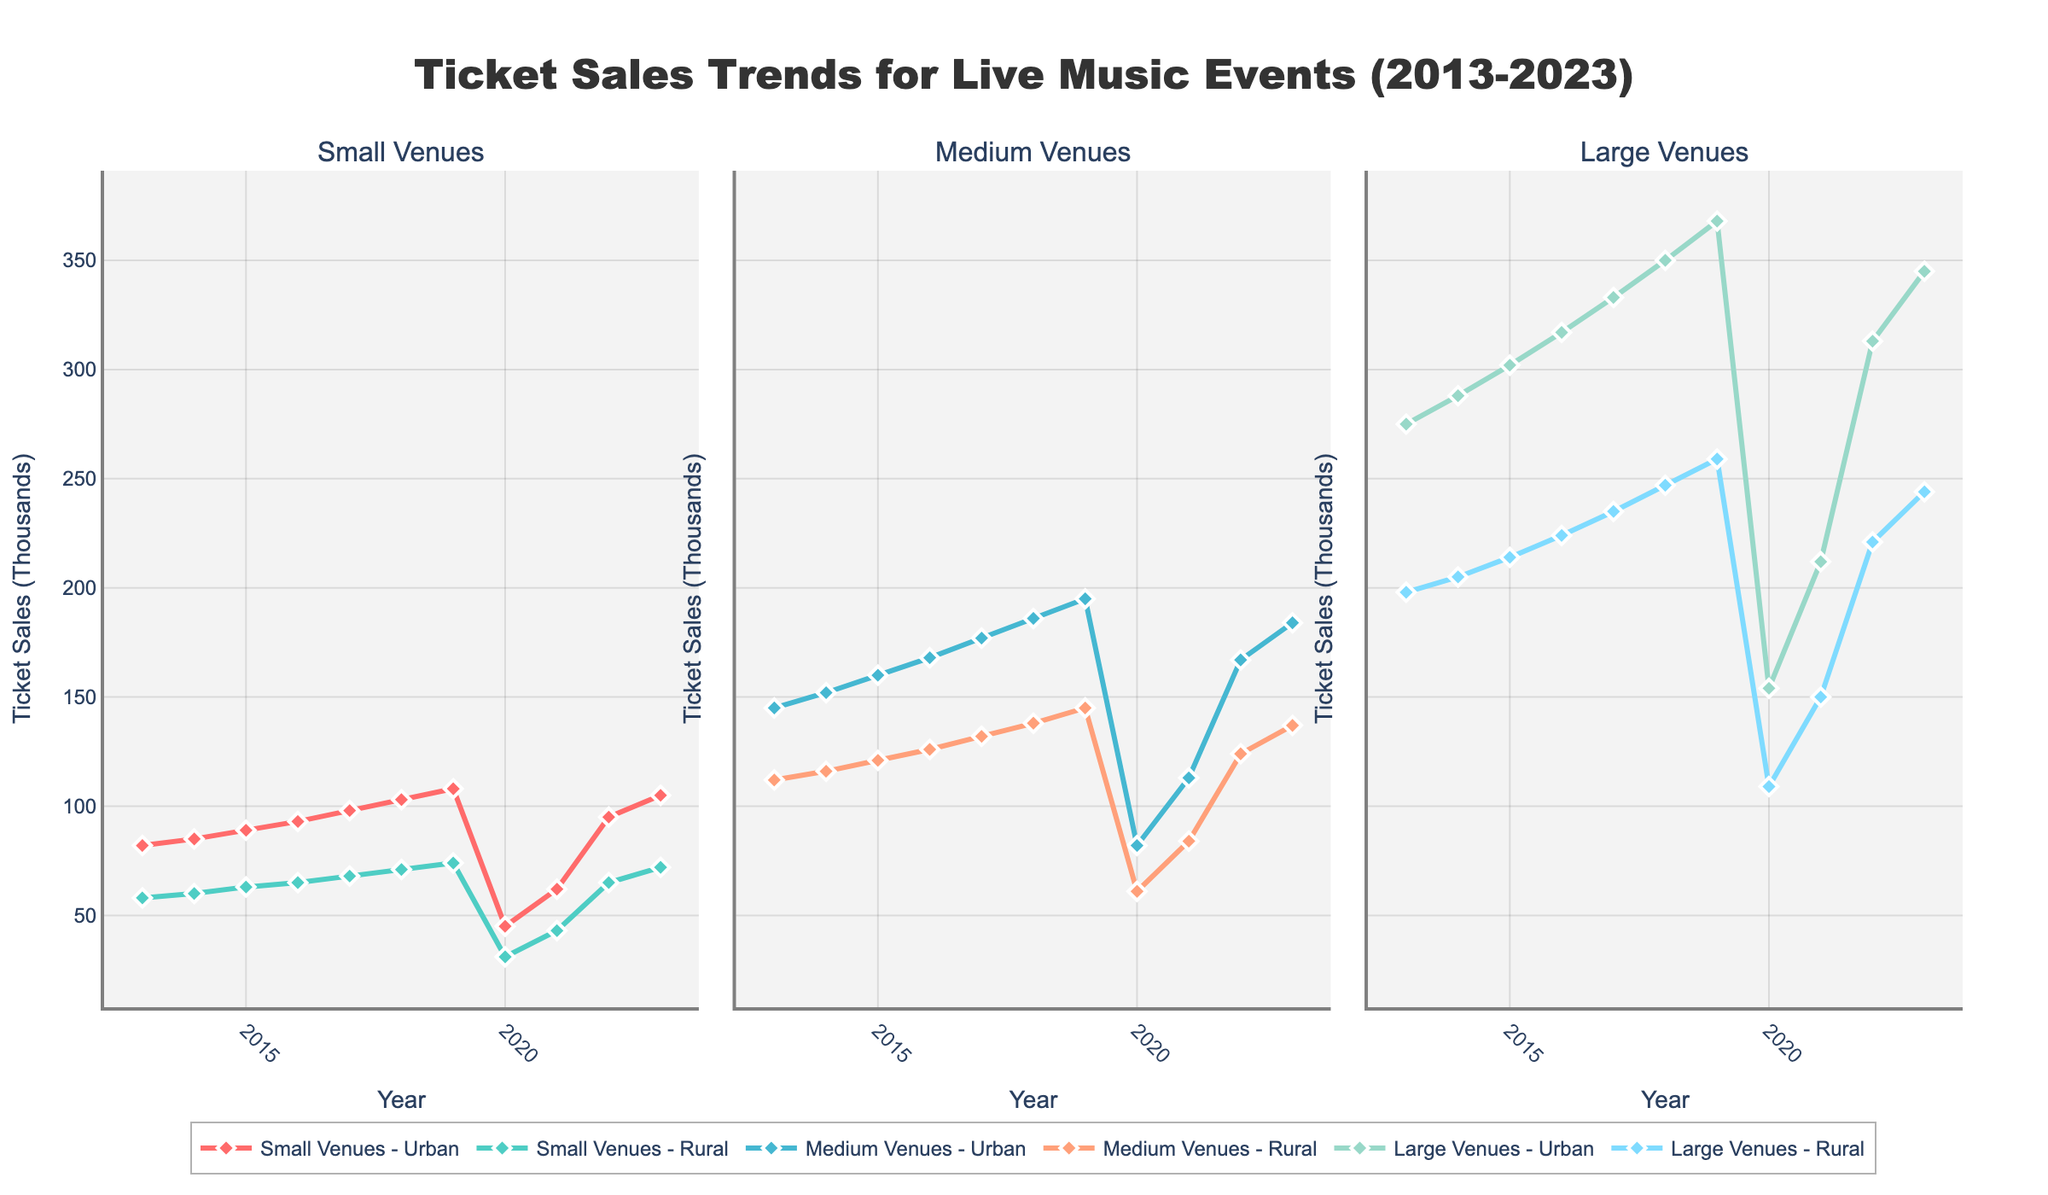How did ticket sales for large venues in urban locations change from 2013 to 2023? Ticket sales for large venues in urban locations increased from 275,000 in 2013 to 345,000 in 2023, which indicates a positive trend. To answer, we locate the 2013 and 2023 data points for large venues in urban locations and observe the rise in values.
Answer: Increased from 275,000 to 345,000 Which venue type and location experienced the greatest decrease in ticket sales in 2020 compared to 2019? The greatest decrease is observed by comparing 2019 and 2020 ticket sales across all venue types and locations. For large venues in urban locations, sales fell from 368,000 in 2019 to 154,000 in 2020. This large drop highlights the significant impact.
Answer: Large Venues Urban By how much did ticket sales for medium venues in rural areas recover from 2020 to 2023? Ticket sales for medium venues in rural areas rose from 61,000 in 2020 to 137,000 in 2023. First, subtract the 2020 value from the 2023 value (137 - 61), resulting in a recovery of 76,000.
Answer: 76,000 Compare the ticket sales trends for small venues in urban and rural locations over the last decade. Analyze both trend lines: small urban venues increased steadily until 2019, dropped in 2020, and then recovered, surpassing their previous peak by 2023. Small rural venues show a similar pattern but with lower values throughout.
Answer: Similar pattern with lower values in rural What's the average annual ticket sales for large venues in rural areas from 2013 to 2023? The average annual ticket sales are calculated by summing the values from 2013 to 2023 and dividing by the count of years. (198 + 205 + 214 + 224 + 235 + 247 + 259 + 109 + 150 + 221 + 244) / 11.
Answer: 212,273 In which year did small venues in urban locations first exceed 100,000 ticket sales? Observe the trend line for small urban venues and identify the first year the value crosses 100,000. In 2018, ticket sales reached 103,000 for small urban venues.
Answer: 2018 How do the trends in large venues compare between urban and rural areas after the 2020 decline? After 2020, ticket sales for both urban and rural large venues recover, but urban areas experience a sharper increase (reaching 345,000), while rural areas grow at a slower pace (up to 244,000).
Answer: Urban areas had a sharper recovery What's the sum of ticket sales for small venues in rural locations from 2013 to 2018? Add the sales figures from 2013 to 2018 for small rural venues (58 + 60 + 63 + 65 + 68 + 71). This results in the total sum of these values.
Answer: 385,000 In how many years did ticket sales for medium venues in urban locations exceed 150,000? Count the instances where the ticket sales for medium urban venues are greater than 150,000 in each year. These occur in 6 out of 11 years (2014 to 2023 excluding 2020 and 2021).
Answer: 6 years 